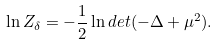<formula> <loc_0><loc_0><loc_500><loc_500>\ln Z _ { \delta } = - { \frac { 1 } { 2 } } \ln d e t ( - \Delta + \mu ^ { 2 } ) .</formula> 